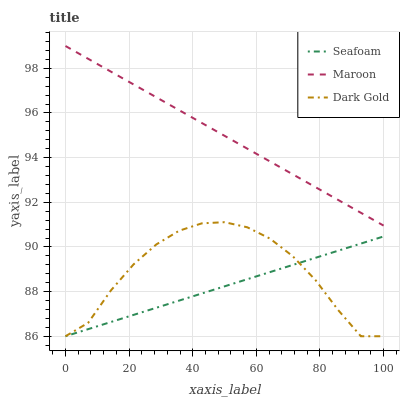Does Seafoam have the minimum area under the curve?
Answer yes or no. Yes. Does Maroon have the maximum area under the curve?
Answer yes or no. Yes. Does Dark Gold have the minimum area under the curve?
Answer yes or no. No. Does Dark Gold have the maximum area under the curve?
Answer yes or no. No. Is Maroon the smoothest?
Answer yes or no. Yes. Is Dark Gold the roughest?
Answer yes or no. Yes. Is Dark Gold the smoothest?
Answer yes or no. No. Is Maroon the roughest?
Answer yes or no. No. Does Seafoam have the lowest value?
Answer yes or no. Yes. Does Maroon have the lowest value?
Answer yes or no. No. Does Maroon have the highest value?
Answer yes or no. Yes. Does Dark Gold have the highest value?
Answer yes or no. No. Is Seafoam less than Maroon?
Answer yes or no. Yes. Is Maroon greater than Dark Gold?
Answer yes or no. Yes. Does Dark Gold intersect Seafoam?
Answer yes or no. Yes. Is Dark Gold less than Seafoam?
Answer yes or no. No. Is Dark Gold greater than Seafoam?
Answer yes or no. No. Does Seafoam intersect Maroon?
Answer yes or no. No. 